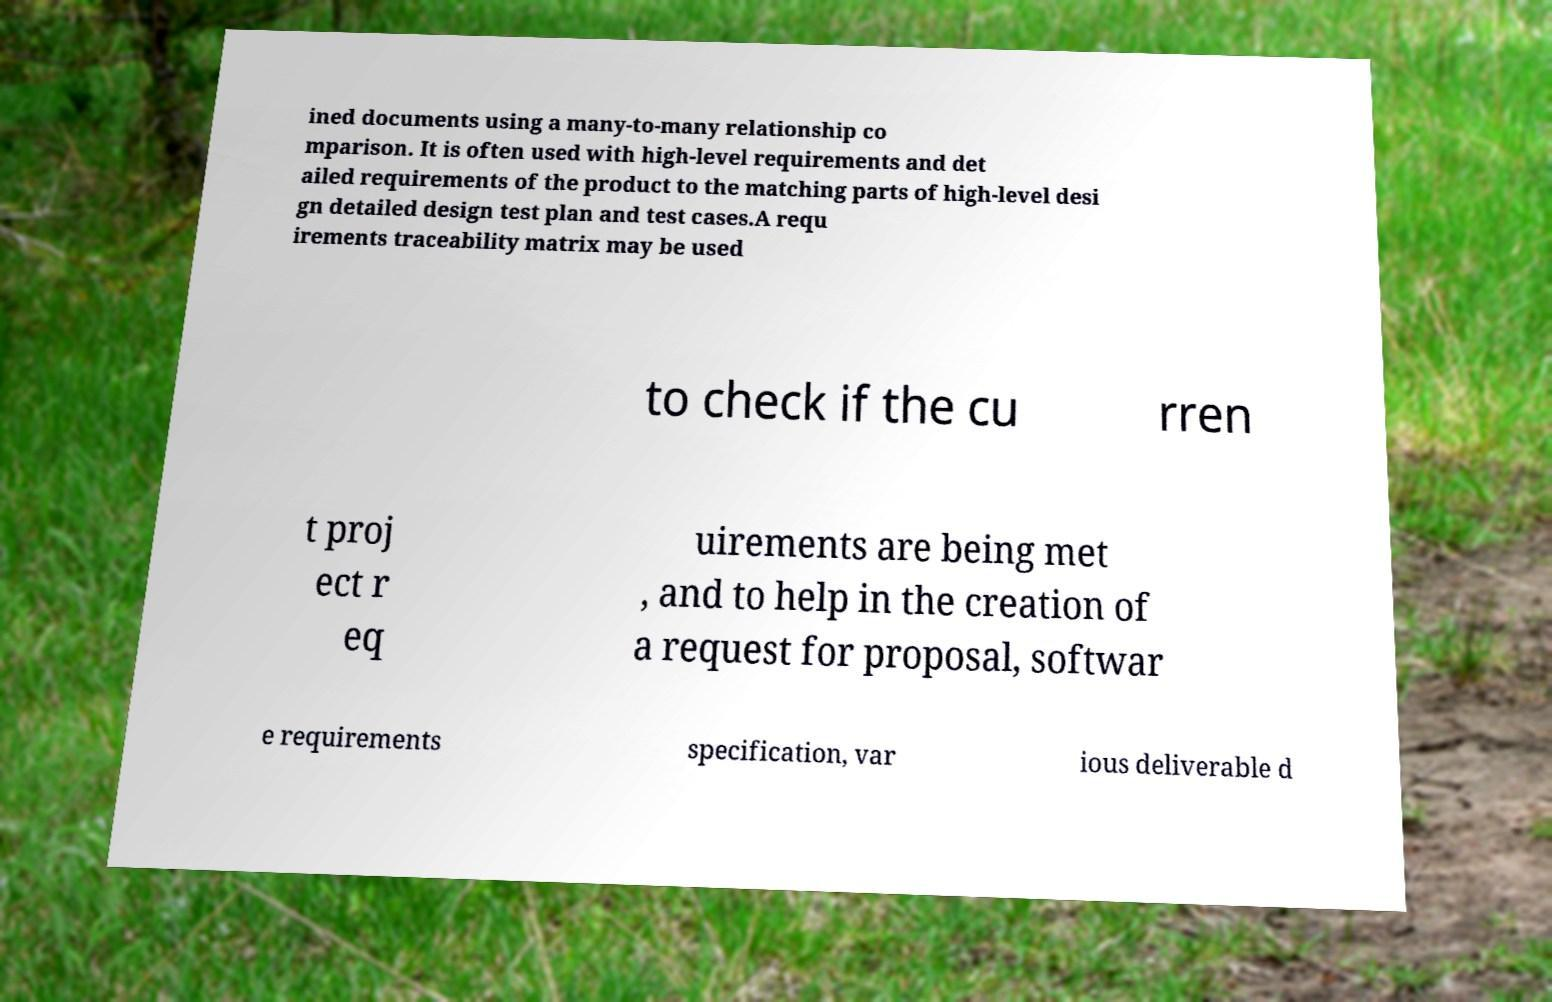Can you accurately transcribe the text from the provided image for me? ined documents using a many-to-many relationship co mparison. It is often used with high-level requirements and det ailed requirements of the product to the matching parts of high-level desi gn detailed design test plan and test cases.A requ irements traceability matrix may be used to check if the cu rren t proj ect r eq uirements are being met , and to help in the creation of a request for proposal, softwar e requirements specification, var ious deliverable d 